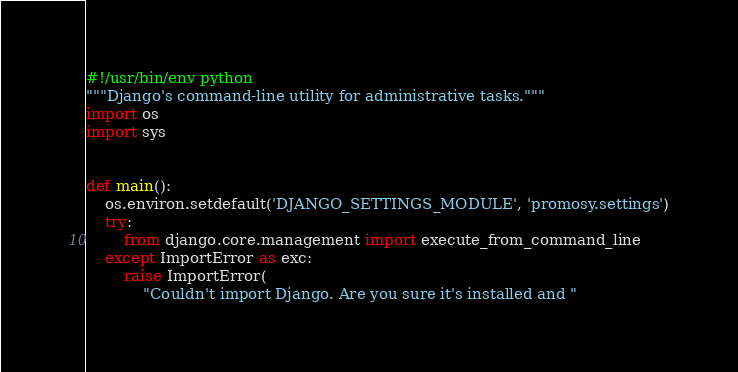Convert code to text. <code><loc_0><loc_0><loc_500><loc_500><_Python_>#!/usr/bin/env python
"""Django's command-line utility for administrative tasks."""
import os
import sys


def main():
    os.environ.setdefault('DJANGO_SETTINGS_MODULE', 'promosy.settings')
    try:
        from django.core.management import execute_from_command_line
    except ImportError as exc:
        raise ImportError(
            "Couldn't import Django. Are you sure it's installed and "</code> 